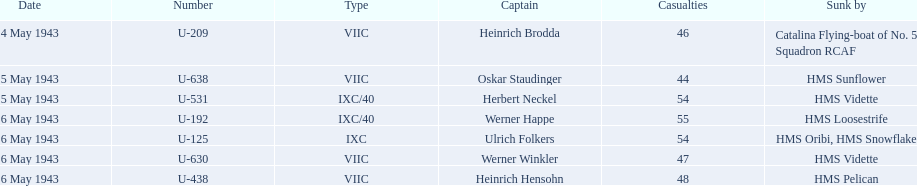What boats were lost on may 5? U-638, U-531. Who were the captains of those boats? Oskar Staudinger, Herbert Neckel. Which captain was not oskar staudinger? Herbert Neckel. 